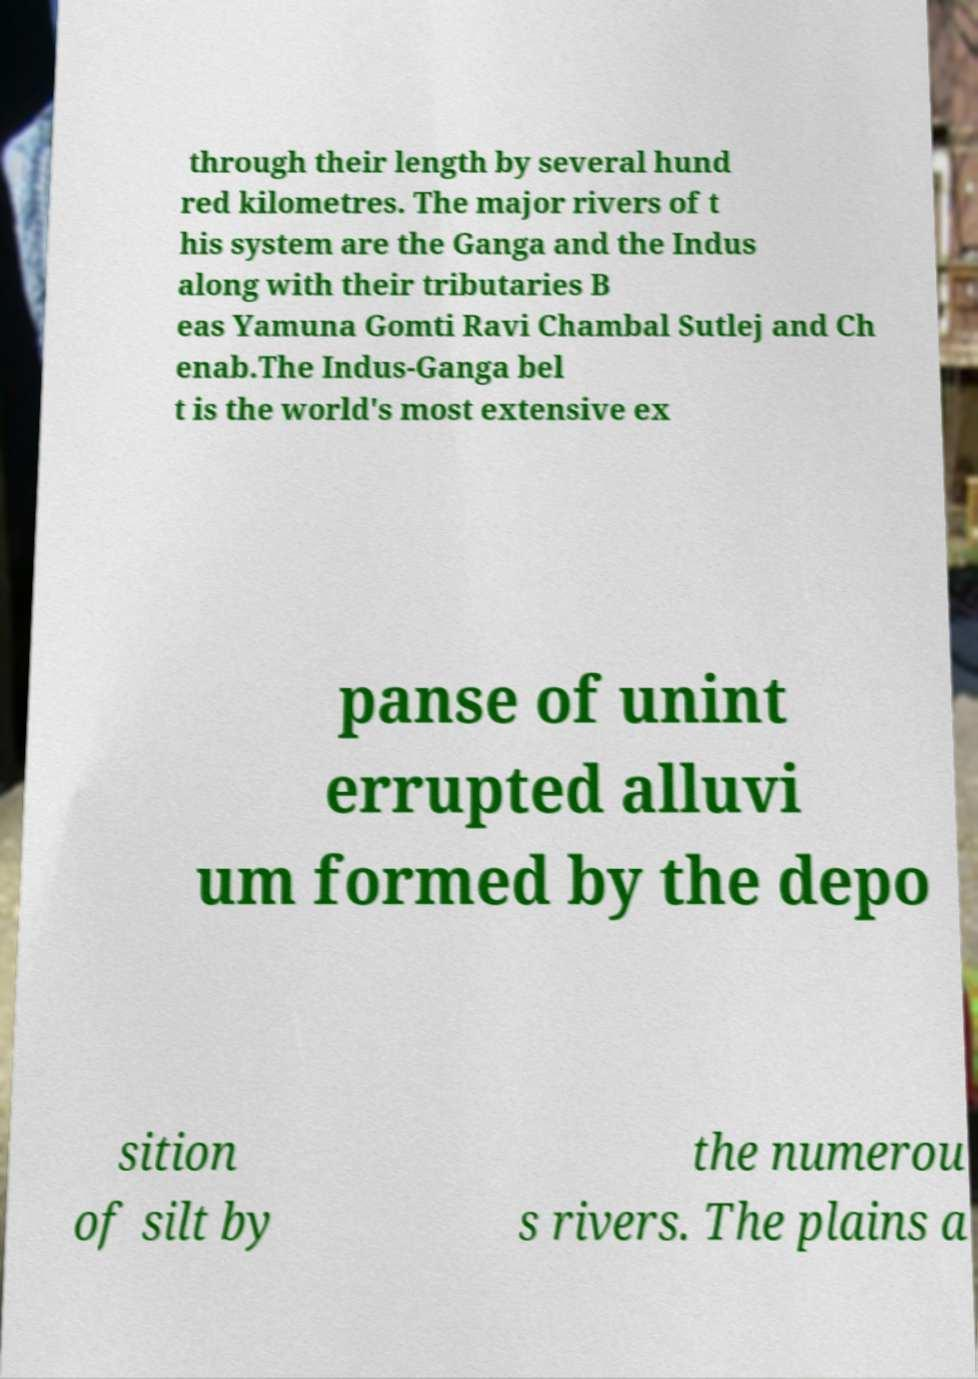I need the written content from this picture converted into text. Can you do that? through their length by several hund red kilometres. The major rivers of t his system are the Ganga and the Indus along with their tributaries B eas Yamuna Gomti Ravi Chambal Sutlej and Ch enab.The Indus-Ganga bel t is the world's most extensive ex panse of unint errupted alluvi um formed by the depo sition of silt by the numerou s rivers. The plains a 